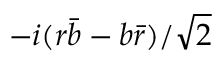Convert formula to latex. <formula><loc_0><loc_0><loc_500><loc_500>- i ( r { \bar { b } } - b { \bar { r } } ) / { \sqrt { 2 } }</formula> 